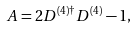<formula> <loc_0><loc_0><loc_500><loc_500>A = 2 D ^ { ( 4 ) \dagger } D ^ { ( 4 ) } - 1 ,</formula> 